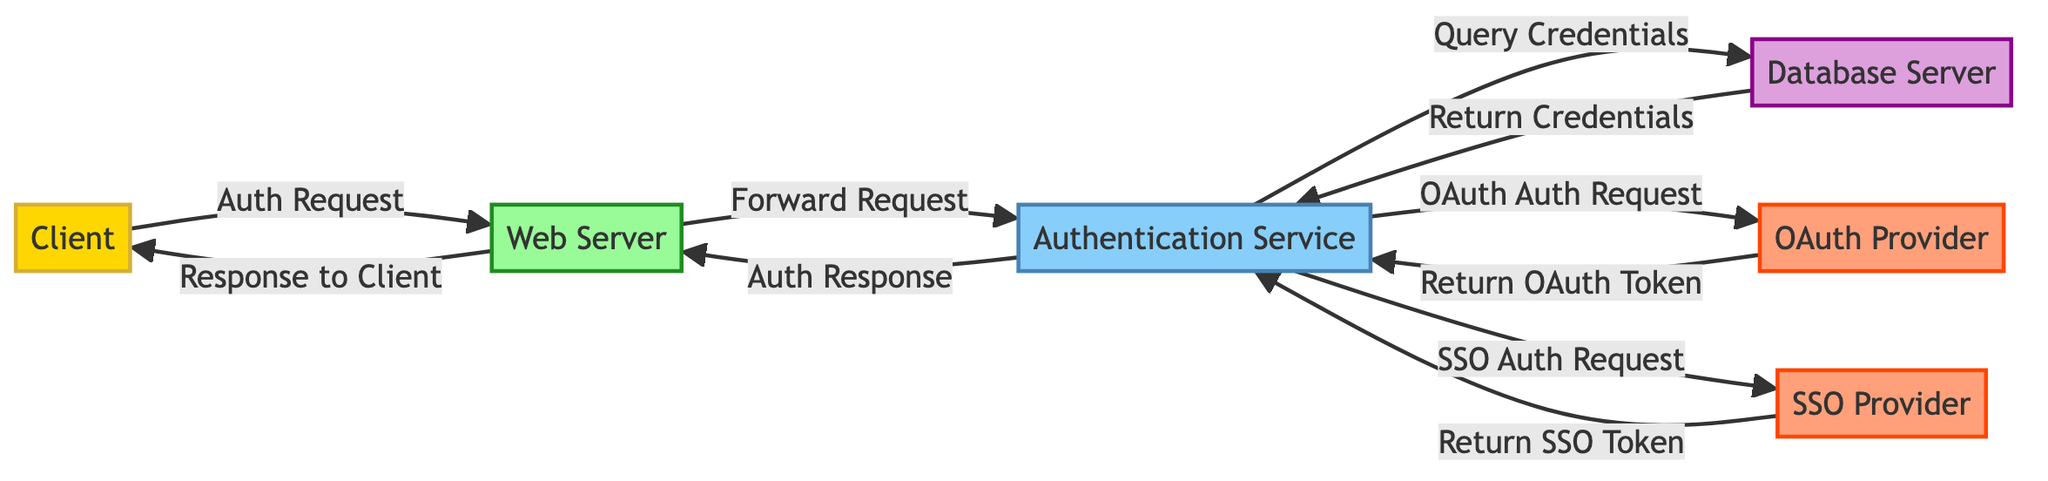What is the main function of the "Authentication Service" node? The "Authentication Service" node is responsible for processing authentication requests and validating credentials. Its role involves handling requests from the web server and checking the user's credentials against the database.
Answer: Processing authentication requests How many nodes are present in the diagram? To determine this, we count all the unique nodes listed in the data provided. There are six nodes: Client, Web Server, Authentication Service, Database Server, OAuth Provider, and SSO Provider.
Answer: Six What is the relationship between the "Web Server" and the "Client"? The relationship is established by the "Auth Request," which indicates that the client sends a login request to the web server. This connection shows that the client initiates the authentication process by contacting the web server.
Answer: Auth Request How does the "Authentication Service" communicate with the "Database Server"? The "Authentication Service" communicates with the "Database Server" through the "Query Credentials" action when it checks for valid user credentials. After that, the database returns the matched credentials back to the authentication service.
Answer: Query Credentials What action does the "Web Server" take after receiving the auth response from the "Authentication Service"? After receiving the auth response from the authentication service, the web server sends the result back to the client, indicating either a successful or failed authentication attempt.
Answer: Response to Client How many external services are illustrated in the diagram? By identifying each external node, we see there are two external services: the OAuth Provider and the SSO Provider, indicating the integration of third-party authentication systems.
Answer: Two What is the process by which the "Authentication Service" obtains an OAuth token? The "Authentication Service" sends an "OAuth Auth Request" to the OAuth Provider, and then the provider returns the OAuth token. This exchange reflects the step where the authentication service interacts with an external identity provider for token validation.
Answer: OAuth Auth Request Which node is responsible for returning the SSO token to the "Authentication Service"? The node responsible for returning the SSO token is the "SSO Provider," reflecting its role in federated identity authentication by supplying tokens after processing the authentication request.
Answer: SSO Provider What type of request does the "Authentication Service" make to the "OAuth Provider"? The type of request made is an "OAuth Auth Request," signifying that the authentication service seeks authentication via OAuth for a user, either to validate or acquire user data from an external provider.
Answer: OAuth Auth Request 